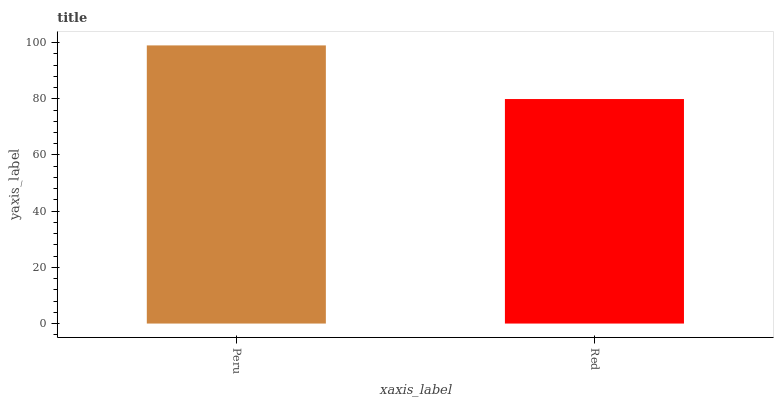Is Red the minimum?
Answer yes or no. Yes. Is Peru the maximum?
Answer yes or no. Yes. Is Red the maximum?
Answer yes or no. No. Is Peru greater than Red?
Answer yes or no. Yes. Is Red less than Peru?
Answer yes or no. Yes. Is Red greater than Peru?
Answer yes or no. No. Is Peru less than Red?
Answer yes or no. No. Is Peru the high median?
Answer yes or no. Yes. Is Red the low median?
Answer yes or no. Yes. Is Red the high median?
Answer yes or no. No. Is Peru the low median?
Answer yes or no. No. 